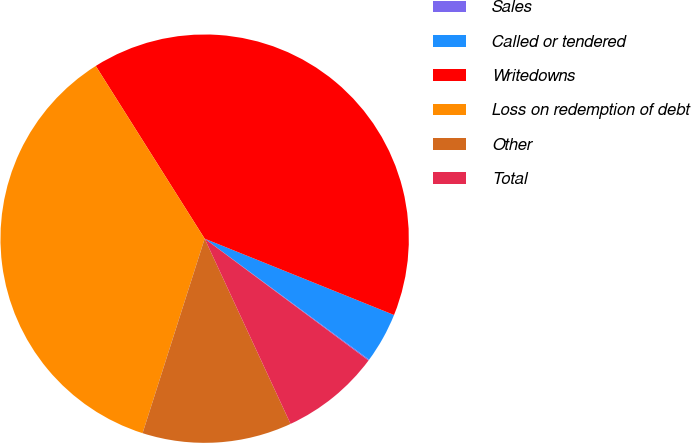Convert chart. <chart><loc_0><loc_0><loc_500><loc_500><pie_chart><fcel>Sales<fcel>Called or tendered<fcel>Writedowns<fcel>Loss on redemption of debt<fcel>Other<fcel>Total<nl><fcel>0.08%<fcel>4.0%<fcel>40.05%<fcel>36.13%<fcel>11.83%<fcel>7.91%<nl></chart> 